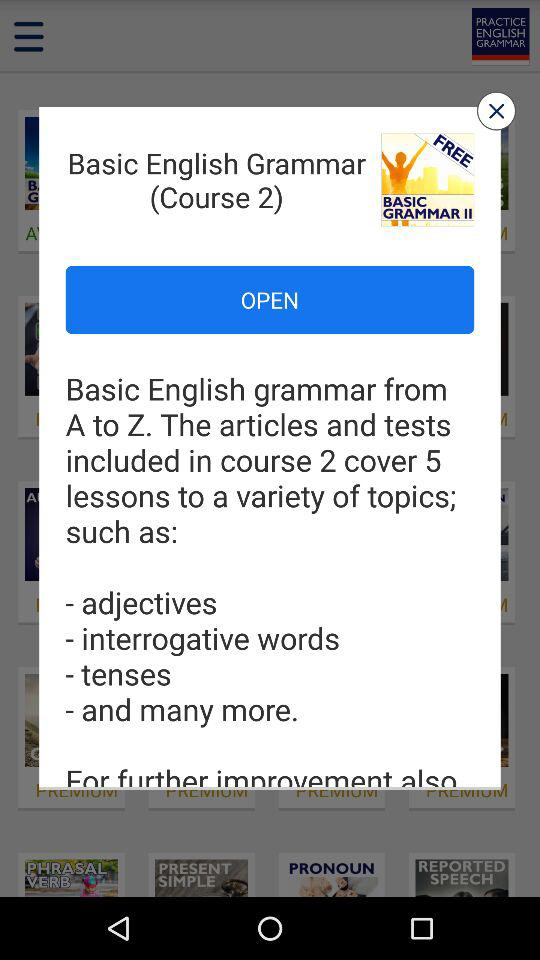How many lessons are included in the course?
Answer the question using a single word or phrase. 5 